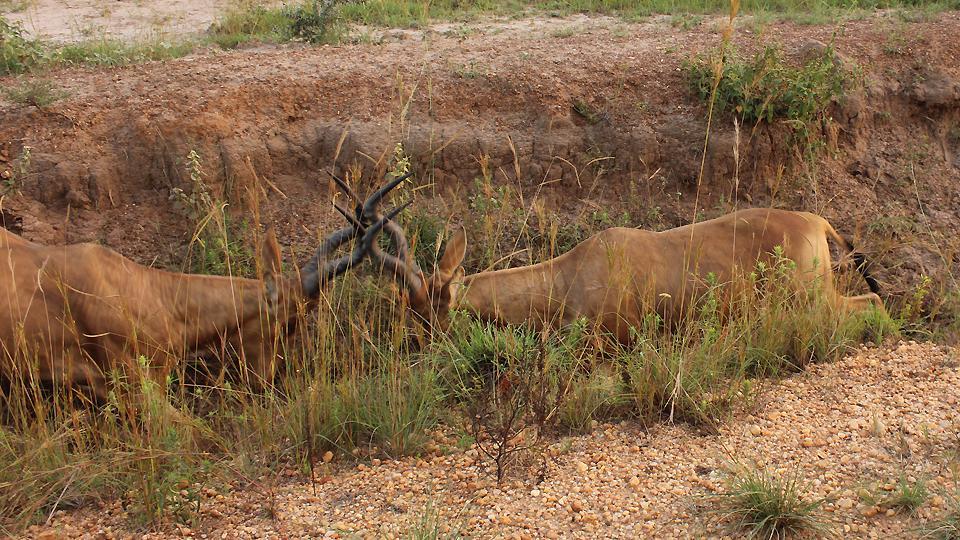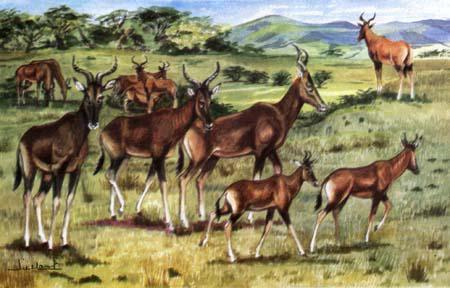The first image is the image on the left, the second image is the image on the right. For the images shown, is this caption "An image shows exactly two horned animals, which are facing each other." true? Answer yes or no. Yes. 